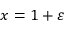<formula> <loc_0><loc_0><loc_500><loc_500>x = 1 + \varepsilon</formula> 